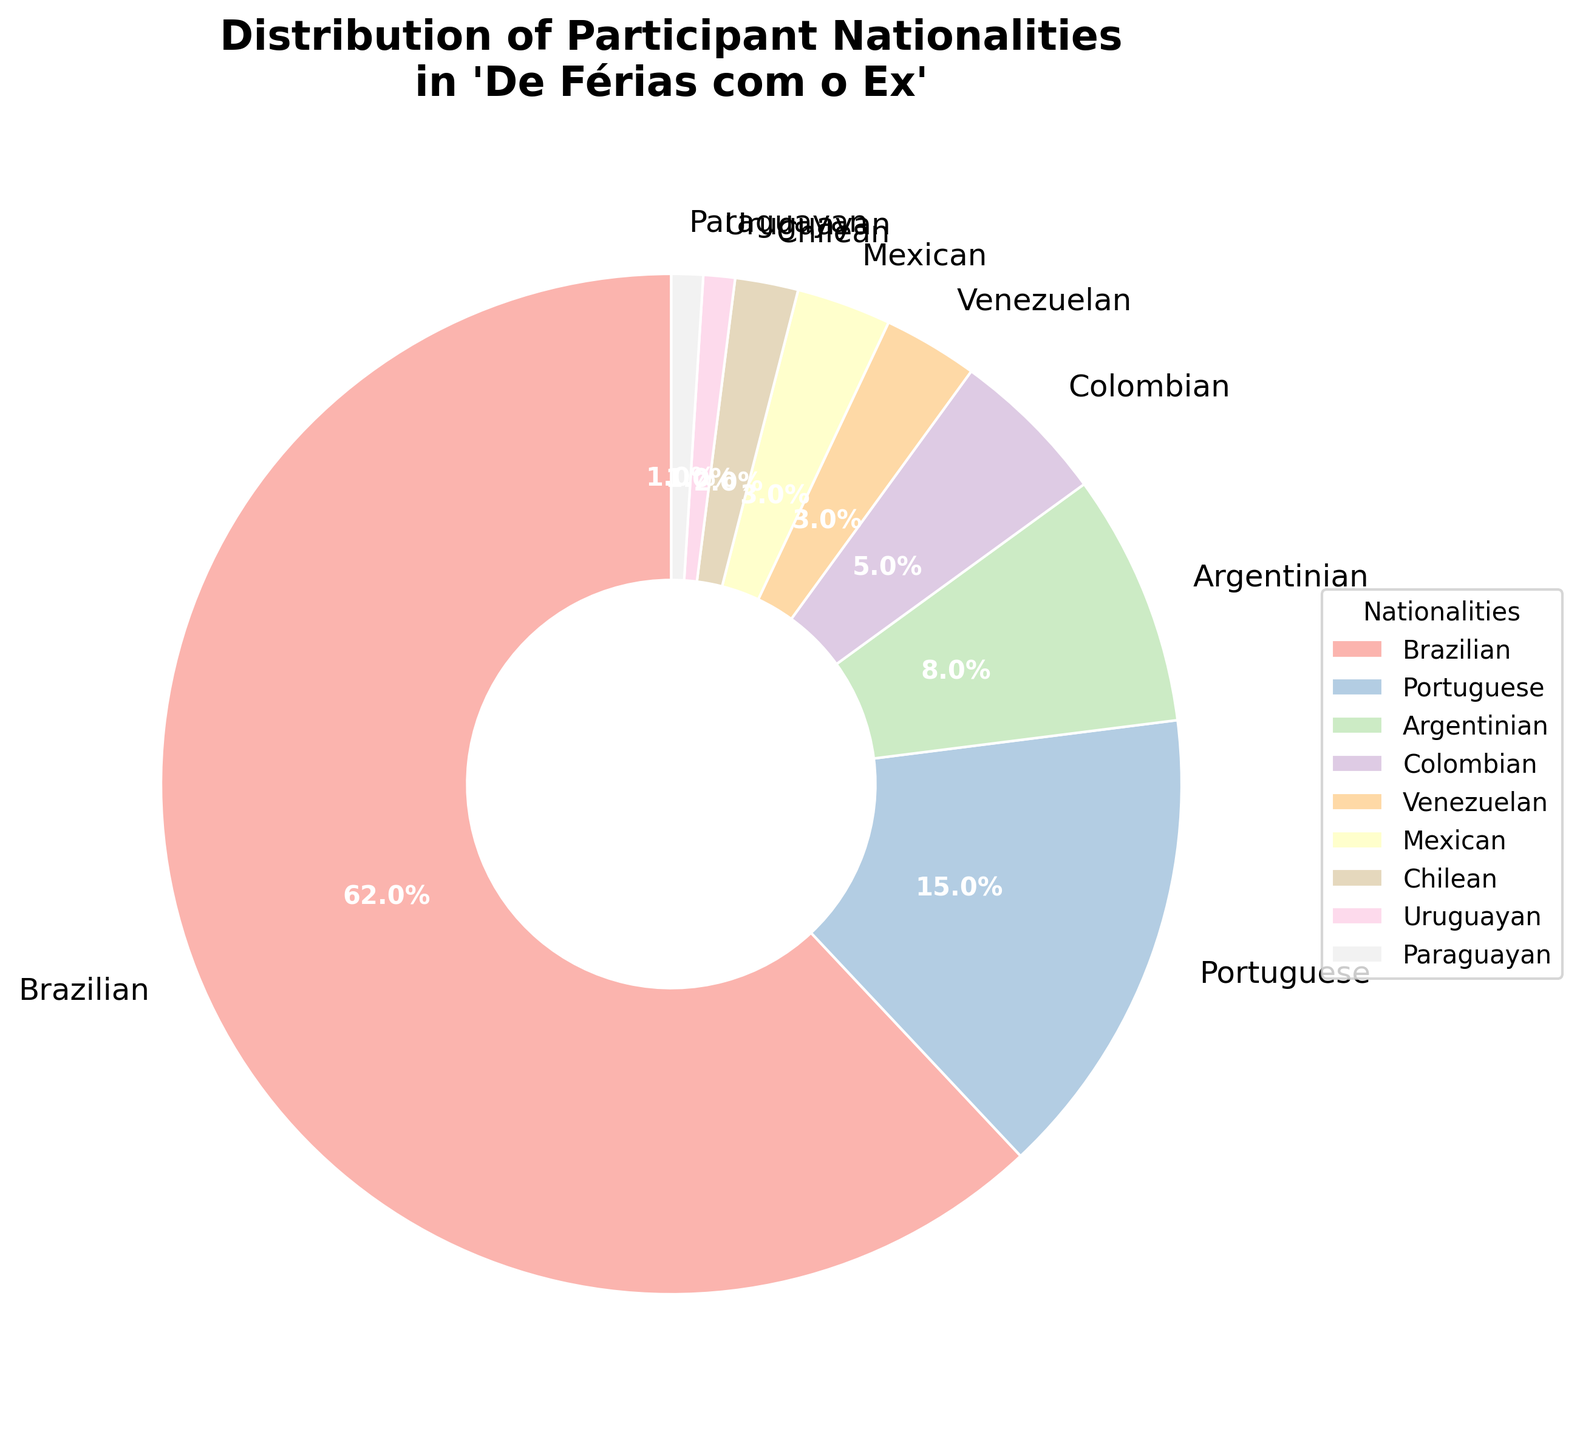what percentage of participants are Brazilian? The pie chart shows the percentage for each nationality. According to the chart, the percentage of Brazilian participants is labeled directly.
Answer: 62% Which two nationalities have the smallest percentages of participants? By looking at the smallest sections in the pie chart, identify the nationalities with the smallest percentage values. The chart shows that the smallest sections correspond to Uruguayan and Paraguayan.
Answer: Uruguayan and Paraguayan What's the total percentage of participants from Argentina, Colombia, and Venezuela combined? Sum the percentages for Argentinian (8%), Colombian (5%), and Venezuelan (3%) participants: 8 + 5 + 3 = 16%.
Answer: 16% Are there more Mexican or Chilean participants? Compare the sizes of the sections corresponding to Mexican and Chilean participants. According to the chart, Mexican participants form a larger section than Chilean participants.
Answer: Mexican What is the difference in the percentage of participants between the largest and smallest nationality groups? The largest pie section represents Brazilian participants (62%) while the smallest sections represent Uruguayan and Paraguayan participants (both 1%). Subtract the smallest value from the largest: 62% - 1% = 61%.
Answer: 61% Which color represents Colombian participants and what is their percentage? Identify the section labeled as Colombian and describe its color, then note the percentage value attached to the label. The color used is specified in the visual attributes (pale shade).
Answer: Pale color, 5% How much larger is the percentage of Portuguese participants compared to Chilean participants? Subtract the percentage of Chilean participants (2%) from the percentage of Portuguese participants (15%): 15% - 2% = 13%.
Answer: 13% If you combine the percentages of Mexican and Venezuelan participants, does it exceed the percentage of Argentinian participants? Sum the percentages for Mexican (3%) and Venezuelan (3%) participants: 3 + 3 = 6%. Compare this to the percentage of Argentinian participants (8%). Since 6% < 8%, it does not exceed.
Answer: No Which nationality group is represented by the color closest to light pink? Scan through the chart and identify the color that resembles light pink and look at the label attached to it. It can be identified as one of the nationalities shown.
Answer: Argentinian 